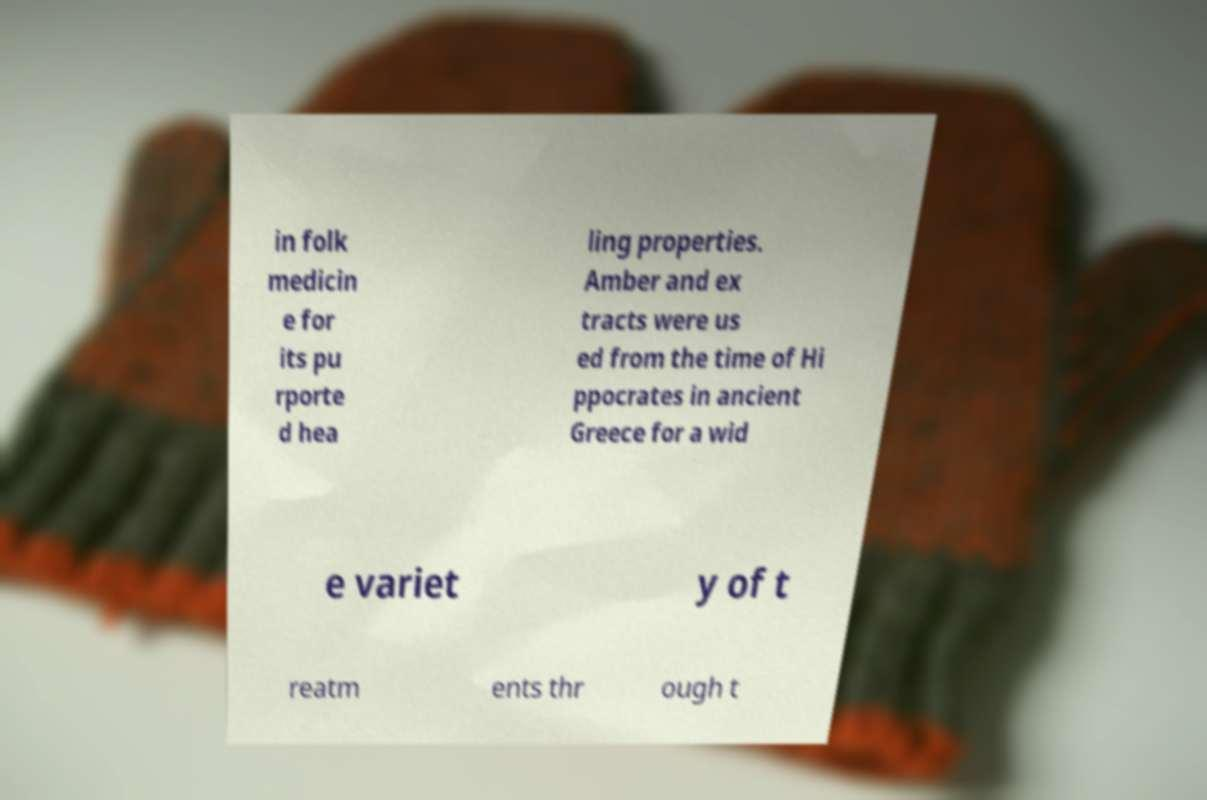What messages or text are displayed in this image? I need them in a readable, typed format. in folk medicin e for its pu rporte d hea ling properties. Amber and ex tracts were us ed from the time of Hi ppocrates in ancient Greece for a wid e variet y of t reatm ents thr ough t 